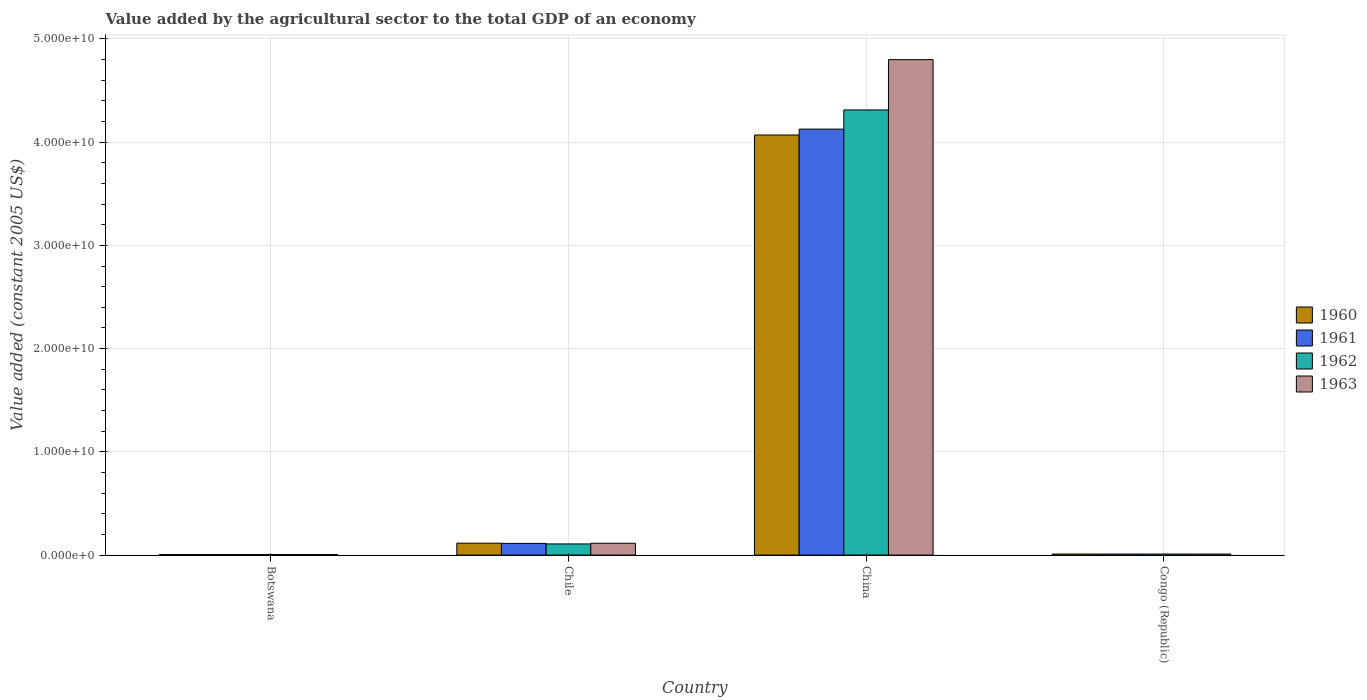Are the number of bars on each tick of the X-axis equal?
Offer a terse response. Yes. How many bars are there on the 1st tick from the left?
Provide a succinct answer. 4. How many bars are there on the 1st tick from the right?
Your answer should be very brief. 4. What is the label of the 2nd group of bars from the left?
Ensure brevity in your answer.  Chile. What is the value added by the agricultural sector in 1960 in China?
Your answer should be very brief. 4.07e+1. Across all countries, what is the maximum value added by the agricultural sector in 1963?
Keep it short and to the point. 4.80e+1. Across all countries, what is the minimum value added by the agricultural sector in 1962?
Keep it short and to the point. 5.04e+07. In which country was the value added by the agricultural sector in 1960 maximum?
Your answer should be very brief. China. In which country was the value added by the agricultural sector in 1963 minimum?
Your answer should be compact. Botswana. What is the total value added by the agricultural sector in 1960 in the graph?
Ensure brevity in your answer.  4.20e+1. What is the difference between the value added by the agricultural sector in 1960 in Botswana and that in China?
Give a very brief answer. -4.07e+1. What is the difference between the value added by the agricultural sector in 1963 in Chile and the value added by the agricultural sector in 1960 in Congo (Republic)?
Make the answer very short. 1.05e+09. What is the average value added by the agricultural sector in 1961 per country?
Your response must be concise. 1.06e+1. What is the difference between the value added by the agricultural sector of/in 1962 and value added by the agricultural sector of/in 1963 in Congo (Republic)?
Offer a very short reply. -6.85e+05. In how many countries, is the value added by the agricultural sector in 1963 greater than 34000000000 US$?
Offer a terse response. 1. What is the ratio of the value added by the agricultural sector in 1962 in Botswana to that in Congo (Republic)?
Offer a terse response. 0.51. Is the difference between the value added by the agricultural sector in 1962 in Chile and China greater than the difference between the value added by the agricultural sector in 1963 in Chile and China?
Ensure brevity in your answer.  Yes. What is the difference between the highest and the second highest value added by the agricultural sector in 1961?
Make the answer very short. 1.03e+09. What is the difference between the highest and the lowest value added by the agricultural sector in 1963?
Your answer should be compact. 4.79e+1. Is it the case that in every country, the sum of the value added by the agricultural sector in 1960 and value added by the agricultural sector in 1962 is greater than the value added by the agricultural sector in 1961?
Give a very brief answer. Yes. Are all the bars in the graph horizontal?
Keep it short and to the point. No. How many countries are there in the graph?
Offer a very short reply. 4. What is the difference between two consecutive major ticks on the Y-axis?
Provide a short and direct response. 1.00e+1. Does the graph contain any zero values?
Give a very brief answer. No. Does the graph contain grids?
Your answer should be very brief. Yes. Where does the legend appear in the graph?
Offer a very short reply. Center right. What is the title of the graph?
Give a very brief answer. Value added by the agricultural sector to the total GDP of an economy. What is the label or title of the X-axis?
Your response must be concise. Country. What is the label or title of the Y-axis?
Provide a succinct answer. Value added (constant 2005 US$). What is the Value added (constant 2005 US$) in 1960 in Botswana?
Your response must be concise. 4.74e+07. What is the Value added (constant 2005 US$) of 1961 in Botswana?
Provide a short and direct response. 4.86e+07. What is the Value added (constant 2005 US$) of 1962 in Botswana?
Ensure brevity in your answer.  5.04e+07. What is the Value added (constant 2005 US$) in 1963 in Botswana?
Offer a very short reply. 5.21e+07. What is the Value added (constant 2005 US$) in 1960 in Chile?
Your answer should be very brief. 1.15e+09. What is the Value added (constant 2005 US$) of 1961 in Chile?
Make the answer very short. 1.13e+09. What is the Value added (constant 2005 US$) in 1962 in Chile?
Your response must be concise. 1.08e+09. What is the Value added (constant 2005 US$) in 1963 in Chile?
Give a very brief answer. 1.15e+09. What is the Value added (constant 2005 US$) of 1960 in China?
Offer a terse response. 4.07e+1. What is the Value added (constant 2005 US$) in 1961 in China?
Provide a succinct answer. 4.13e+1. What is the Value added (constant 2005 US$) in 1962 in China?
Ensure brevity in your answer.  4.31e+1. What is the Value added (constant 2005 US$) in 1963 in China?
Give a very brief answer. 4.80e+1. What is the Value added (constant 2005 US$) of 1960 in Congo (Republic)?
Offer a terse response. 1.01e+08. What is the Value added (constant 2005 US$) of 1961 in Congo (Republic)?
Your response must be concise. 9.74e+07. What is the Value added (constant 2005 US$) of 1962 in Congo (Republic)?
Keep it short and to the point. 9.79e+07. What is the Value added (constant 2005 US$) in 1963 in Congo (Republic)?
Your answer should be very brief. 9.86e+07. Across all countries, what is the maximum Value added (constant 2005 US$) of 1960?
Make the answer very short. 4.07e+1. Across all countries, what is the maximum Value added (constant 2005 US$) of 1961?
Give a very brief answer. 4.13e+1. Across all countries, what is the maximum Value added (constant 2005 US$) of 1962?
Provide a succinct answer. 4.31e+1. Across all countries, what is the maximum Value added (constant 2005 US$) of 1963?
Your answer should be compact. 4.80e+1. Across all countries, what is the minimum Value added (constant 2005 US$) in 1960?
Provide a short and direct response. 4.74e+07. Across all countries, what is the minimum Value added (constant 2005 US$) of 1961?
Your answer should be very brief. 4.86e+07. Across all countries, what is the minimum Value added (constant 2005 US$) of 1962?
Make the answer very short. 5.04e+07. Across all countries, what is the minimum Value added (constant 2005 US$) in 1963?
Provide a succinct answer. 5.21e+07. What is the total Value added (constant 2005 US$) in 1960 in the graph?
Provide a succinct answer. 4.20e+1. What is the total Value added (constant 2005 US$) of 1961 in the graph?
Ensure brevity in your answer.  4.25e+1. What is the total Value added (constant 2005 US$) in 1962 in the graph?
Make the answer very short. 4.44e+1. What is the total Value added (constant 2005 US$) of 1963 in the graph?
Give a very brief answer. 4.93e+1. What is the difference between the Value added (constant 2005 US$) of 1960 in Botswana and that in Chile?
Ensure brevity in your answer.  -1.10e+09. What is the difference between the Value added (constant 2005 US$) in 1961 in Botswana and that in Chile?
Ensure brevity in your answer.  -1.08e+09. What is the difference between the Value added (constant 2005 US$) in 1962 in Botswana and that in Chile?
Give a very brief answer. -1.03e+09. What is the difference between the Value added (constant 2005 US$) of 1963 in Botswana and that in Chile?
Your response must be concise. -1.09e+09. What is the difference between the Value added (constant 2005 US$) of 1960 in Botswana and that in China?
Give a very brief answer. -4.07e+1. What is the difference between the Value added (constant 2005 US$) in 1961 in Botswana and that in China?
Ensure brevity in your answer.  -4.12e+1. What is the difference between the Value added (constant 2005 US$) of 1962 in Botswana and that in China?
Offer a terse response. -4.31e+1. What is the difference between the Value added (constant 2005 US$) in 1963 in Botswana and that in China?
Offer a terse response. -4.79e+1. What is the difference between the Value added (constant 2005 US$) of 1960 in Botswana and that in Congo (Republic)?
Make the answer very short. -5.35e+07. What is the difference between the Value added (constant 2005 US$) in 1961 in Botswana and that in Congo (Republic)?
Offer a terse response. -4.87e+07. What is the difference between the Value added (constant 2005 US$) in 1962 in Botswana and that in Congo (Republic)?
Offer a terse response. -4.76e+07. What is the difference between the Value added (constant 2005 US$) in 1963 in Botswana and that in Congo (Republic)?
Your answer should be compact. -4.65e+07. What is the difference between the Value added (constant 2005 US$) of 1960 in Chile and that in China?
Keep it short and to the point. -3.95e+1. What is the difference between the Value added (constant 2005 US$) of 1961 in Chile and that in China?
Give a very brief answer. -4.01e+1. What is the difference between the Value added (constant 2005 US$) of 1962 in Chile and that in China?
Offer a very short reply. -4.20e+1. What is the difference between the Value added (constant 2005 US$) in 1963 in Chile and that in China?
Your response must be concise. -4.69e+1. What is the difference between the Value added (constant 2005 US$) of 1960 in Chile and that in Congo (Republic)?
Your response must be concise. 1.05e+09. What is the difference between the Value added (constant 2005 US$) of 1961 in Chile and that in Congo (Republic)?
Give a very brief answer. 1.03e+09. What is the difference between the Value added (constant 2005 US$) of 1962 in Chile and that in Congo (Republic)?
Give a very brief answer. 9.81e+08. What is the difference between the Value added (constant 2005 US$) in 1963 in Chile and that in Congo (Republic)?
Offer a very short reply. 1.05e+09. What is the difference between the Value added (constant 2005 US$) of 1960 in China and that in Congo (Republic)?
Provide a succinct answer. 4.06e+1. What is the difference between the Value added (constant 2005 US$) in 1961 in China and that in Congo (Republic)?
Offer a very short reply. 4.12e+1. What is the difference between the Value added (constant 2005 US$) in 1962 in China and that in Congo (Republic)?
Ensure brevity in your answer.  4.30e+1. What is the difference between the Value added (constant 2005 US$) of 1963 in China and that in Congo (Republic)?
Provide a short and direct response. 4.79e+1. What is the difference between the Value added (constant 2005 US$) in 1960 in Botswana and the Value added (constant 2005 US$) in 1961 in Chile?
Give a very brief answer. -1.08e+09. What is the difference between the Value added (constant 2005 US$) of 1960 in Botswana and the Value added (constant 2005 US$) of 1962 in Chile?
Offer a terse response. -1.03e+09. What is the difference between the Value added (constant 2005 US$) in 1960 in Botswana and the Value added (constant 2005 US$) in 1963 in Chile?
Keep it short and to the point. -1.10e+09. What is the difference between the Value added (constant 2005 US$) of 1961 in Botswana and the Value added (constant 2005 US$) of 1962 in Chile?
Keep it short and to the point. -1.03e+09. What is the difference between the Value added (constant 2005 US$) of 1961 in Botswana and the Value added (constant 2005 US$) of 1963 in Chile?
Ensure brevity in your answer.  -1.10e+09. What is the difference between the Value added (constant 2005 US$) in 1962 in Botswana and the Value added (constant 2005 US$) in 1963 in Chile?
Offer a terse response. -1.10e+09. What is the difference between the Value added (constant 2005 US$) of 1960 in Botswana and the Value added (constant 2005 US$) of 1961 in China?
Your answer should be very brief. -4.12e+1. What is the difference between the Value added (constant 2005 US$) in 1960 in Botswana and the Value added (constant 2005 US$) in 1962 in China?
Provide a short and direct response. -4.31e+1. What is the difference between the Value added (constant 2005 US$) in 1960 in Botswana and the Value added (constant 2005 US$) in 1963 in China?
Your answer should be compact. -4.80e+1. What is the difference between the Value added (constant 2005 US$) of 1961 in Botswana and the Value added (constant 2005 US$) of 1962 in China?
Provide a short and direct response. -4.31e+1. What is the difference between the Value added (constant 2005 US$) in 1961 in Botswana and the Value added (constant 2005 US$) in 1963 in China?
Provide a succinct answer. -4.79e+1. What is the difference between the Value added (constant 2005 US$) in 1962 in Botswana and the Value added (constant 2005 US$) in 1963 in China?
Offer a very short reply. -4.79e+1. What is the difference between the Value added (constant 2005 US$) of 1960 in Botswana and the Value added (constant 2005 US$) of 1961 in Congo (Republic)?
Offer a terse response. -4.99e+07. What is the difference between the Value added (constant 2005 US$) of 1960 in Botswana and the Value added (constant 2005 US$) of 1962 in Congo (Republic)?
Offer a very short reply. -5.05e+07. What is the difference between the Value added (constant 2005 US$) in 1960 in Botswana and the Value added (constant 2005 US$) in 1963 in Congo (Republic)?
Keep it short and to the point. -5.12e+07. What is the difference between the Value added (constant 2005 US$) of 1961 in Botswana and the Value added (constant 2005 US$) of 1962 in Congo (Republic)?
Keep it short and to the point. -4.93e+07. What is the difference between the Value added (constant 2005 US$) of 1961 in Botswana and the Value added (constant 2005 US$) of 1963 in Congo (Republic)?
Offer a very short reply. -5.00e+07. What is the difference between the Value added (constant 2005 US$) in 1962 in Botswana and the Value added (constant 2005 US$) in 1963 in Congo (Republic)?
Keep it short and to the point. -4.83e+07. What is the difference between the Value added (constant 2005 US$) of 1960 in Chile and the Value added (constant 2005 US$) of 1961 in China?
Offer a very short reply. -4.01e+1. What is the difference between the Value added (constant 2005 US$) in 1960 in Chile and the Value added (constant 2005 US$) in 1962 in China?
Your answer should be compact. -4.20e+1. What is the difference between the Value added (constant 2005 US$) in 1960 in Chile and the Value added (constant 2005 US$) in 1963 in China?
Give a very brief answer. -4.68e+1. What is the difference between the Value added (constant 2005 US$) of 1961 in Chile and the Value added (constant 2005 US$) of 1962 in China?
Provide a succinct answer. -4.20e+1. What is the difference between the Value added (constant 2005 US$) of 1961 in Chile and the Value added (constant 2005 US$) of 1963 in China?
Provide a short and direct response. -4.69e+1. What is the difference between the Value added (constant 2005 US$) of 1962 in Chile and the Value added (constant 2005 US$) of 1963 in China?
Make the answer very short. -4.69e+1. What is the difference between the Value added (constant 2005 US$) in 1960 in Chile and the Value added (constant 2005 US$) in 1961 in Congo (Republic)?
Provide a succinct answer. 1.05e+09. What is the difference between the Value added (constant 2005 US$) of 1960 in Chile and the Value added (constant 2005 US$) of 1962 in Congo (Republic)?
Make the answer very short. 1.05e+09. What is the difference between the Value added (constant 2005 US$) in 1960 in Chile and the Value added (constant 2005 US$) in 1963 in Congo (Republic)?
Your response must be concise. 1.05e+09. What is the difference between the Value added (constant 2005 US$) in 1961 in Chile and the Value added (constant 2005 US$) in 1962 in Congo (Republic)?
Make the answer very short. 1.03e+09. What is the difference between the Value added (constant 2005 US$) in 1961 in Chile and the Value added (constant 2005 US$) in 1963 in Congo (Republic)?
Offer a very short reply. 1.03e+09. What is the difference between the Value added (constant 2005 US$) in 1962 in Chile and the Value added (constant 2005 US$) in 1963 in Congo (Republic)?
Your answer should be compact. 9.81e+08. What is the difference between the Value added (constant 2005 US$) of 1960 in China and the Value added (constant 2005 US$) of 1961 in Congo (Republic)?
Offer a terse response. 4.06e+1. What is the difference between the Value added (constant 2005 US$) of 1960 in China and the Value added (constant 2005 US$) of 1962 in Congo (Republic)?
Offer a terse response. 4.06e+1. What is the difference between the Value added (constant 2005 US$) in 1960 in China and the Value added (constant 2005 US$) in 1963 in Congo (Republic)?
Make the answer very short. 4.06e+1. What is the difference between the Value added (constant 2005 US$) of 1961 in China and the Value added (constant 2005 US$) of 1962 in Congo (Republic)?
Make the answer very short. 4.12e+1. What is the difference between the Value added (constant 2005 US$) of 1961 in China and the Value added (constant 2005 US$) of 1963 in Congo (Republic)?
Give a very brief answer. 4.12e+1. What is the difference between the Value added (constant 2005 US$) in 1962 in China and the Value added (constant 2005 US$) in 1963 in Congo (Republic)?
Ensure brevity in your answer.  4.30e+1. What is the average Value added (constant 2005 US$) of 1960 per country?
Provide a succinct answer. 1.05e+1. What is the average Value added (constant 2005 US$) of 1961 per country?
Keep it short and to the point. 1.06e+1. What is the average Value added (constant 2005 US$) of 1962 per country?
Ensure brevity in your answer.  1.11e+1. What is the average Value added (constant 2005 US$) in 1963 per country?
Ensure brevity in your answer.  1.23e+1. What is the difference between the Value added (constant 2005 US$) in 1960 and Value added (constant 2005 US$) in 1961 in Botswana?
Provide a short and direct response. -1.17e+06. What is the difference between the Value added (constant 2005 US$) of 1960 and Value added (constant 2005 US$) of 1962 in Botswana?
Keep it short and to the point. -2.92e+06. What is the difference between the Value added (constant 2005 US$) of 1960 and Value added (constant 2005 US$) of 1963 in Botswana?
Offer a terse response. -4.67e+06. What is the difference between the Value added (constant 2005 US$) in 1961 and Value added (constant 2005 US$) in 1962 in Botswana?
Your answer should be very brief. -1.75e+06. What is the difference between the Value added (constant 2005 US$) of 1961 and Value added (constant 2005 US$) of 1963 in Botswana?
Offer a terse response. -3.51e+06. What is the difference between the Value added (constant 2005 US$) in 1962 and Value added (constant 2005 US$) in 1963 in Botswana?
Make the answer very short. -1.75e+06. What is the difference between the Value added (constant 2005 US$) of 1960 and Value added (constant 2005 US$) of 1961 in Chile?
Your answer should be very brief. 2.12e+07. What is the difference between the Value added (constant 2005 US$) in 1960 and Value added (constant 2005 US$) in 1962 in Chile?
Make the answer very short. 7.27e+07. What is the difference between the Value added (constant 2005 US$) in 1960 and Value added (constant 2005 US$) in 1963 in Chile?
Your answer should be very brief. 5.74e+06. What is the difference between the Value added (constant 2005 US$) of 1961 and Value added (constant 2005 US$) of 1962 in Chile?
Offer a very short reply. 5.15e+07. What is the difference between the Value added (constant 2005 US$) of 1961 and Value added (constant 2005 US$) of 1963 in Chile?
Ensure brevity in your answer.  -1.54e+07. What is the difference between the Value added (constant 2005 US$) in 1962 and Value added (constant 2005 US$) in 1963 in Chile?
Offer a very short reply. -6.69e+07. What is the difference between the Value added (constant 2005 US$) of 1960 and Value added (constant 2005 US$) of 1961 in China?
Offer a terse response. -5.70e+08. What is the difference between the Value added (constant 2005 US$) in 1960 and Value added (constant 2005 US$) in 1962 in China?
Make the answer very short. -2.43e+09. What is the difference between the Value added (constant 2005 US$) in 1960 and Value added (constant 2005 US$) in 1963 in China?
Provide a succinct answer. -7.30e+09. What is the difference between the Value added (constant 2005 US$) of 1961 and Value added (constant 2005 US$) of 1962 in China?
Your response must be concise. -1.86e+09. What is the difference between the Value added (constant 2005 US$) in 1961 and Value added (constant 2005 US$) in 1963 in China?
Offer a very short reply. -6.73e+09. What is the difference between the Value added (constant 2005 US$) in 1962 and Value added (constant 2005 US$) in 1963 in China?
Ensure brevity in your answer.  -4.87e+09. What is the difference between the Value added (constant 2005 US$) in 1960 and Value added (constant 2005 US$) in 1961 in Congo (Republic)?
Keep it short and to the point. 3.61e+06. What is the difference between the Value added (constant 2005 US$) in 1960 and Value added (constant 2005 US$) in 1962 in Congo (Republic)?
Provide a succinct answer. 3.02e+06. What is the difference between the Value added (constant 2005 US$) of 1960 and Value added (constant 2005 US$) of 1963 in Congo (Republic)?
Give a very brief answer. 2.34e+06. What is the difference between the Value added (constant 2005 US$) in 1961 and Value added (constant 2005 US$) in 1962 in Congo (Republic)?
Provide a succinct answer. -5.86e+05. What is the difference between the Value added (constant 2005 US$) of 1961 and Value added (constant 2005 US$) of 1963 in Congo (Republic)?
Your answer should be very brief. -1.27e+06. What is the difference between the Value added (constant 2005 US$) of 1962 and Value added (constant 2005 US$) of 1963 in Congo (Republic)?
Ensure brevity in your answer.  -6.85e+05. What is the ratio of the Value added (constant 2005 US$) of 1960 in Botswana to that in Chile?
Provide a short and direct response. 0.04. What is the ratio of the Value added (constant 2005 US$) in 1961 in Botswana to that in Chile?
Make the answer very short. 0.04. What is the ratio of the Value added (constant 2005 US$) in 1962 in Botswana to that in Chile?
Offer a very short reply. 0.05. What is the ratio of the Value added (constant 2005 US$) in 1963 in Botswana to that in Chile?
Provide a succinct answer. 0.05. What is the ratio of the Value added (constant 2005 US$) of 1960 in Botswana to that in China?
Make the answer very short. 0. What is the ratio of the Value added (constant 2005 US$) in 1961 in Botswana to that in China?
Make the answer very short. 0. What is the ratio of the Value added (constant 2005 US$) in 1962 in Botswana to that in China?
Make the answer very short. 0. What is the ratio of the Value added (constant 2005 US$) of 1963 in Botswana to that in China?
Offer a terse response. 0. What is the ratio of the Value added (constant 2005 US$) in 1960 in Botswana to that in Congo (Republic)?
Provide a succinct answer. 0.47. What is the ratio of the Value added (constant 2005 US$) in 1961 in Botswana to that in Congo (Republic)?
Offer a terse response. 0.5. What is the ratio of the Value added (constant 2005 US$) in 1962 in Botswana to that in Congo (Republic)?
Keep it short and to the point. 0.51. What is the ratio of the Value added (constant 2005 US$) in 1963 in Botswana to that in Congo (Republic)?
Provide a succinct answer. 0.53. What is the ratio of the Value added (constant 2005 US$) of 1960 in Chile to that in China?
Keep it short and to the point. 0.03. What is the ratio of the Value added (constant 2005 US$) in 1961 in Chile to that in China?
Offer a very short reply. 0.03. What is the ratio of the Value added (constant 2005 US$) of 1962 in Chile to that in China?
Make the answer very short. 0.03. What is the ratio of the Value added (constant 2005 US$) of 1963 in Chile to that in China?
Give a very brief answer. 0.02. What is the ratio of the Value added (constant 2005 US$) in 1960 in Chile to that in Congo (Republic)?
Your response must be concise. 11.41. What is the ratio of the Value added (constant 2005 US$) in 1961 in Chile to that in Congo (Republic)?
Provide a short and direct response. 11.61. What is the ratio of the Value added (constant 2005 US$) in 1962 in Chile to that in Congo (Republic)?
Make the answer very short. 11.02. What is the ratio of the Value added (constant 2005 US$) in 1963 in Chile to that in Congo (Republic)?
Your response must be concise. 11.62. What is the ratio of the Value added (constant 2005 US$) of 1960 in China to that in Congo (Republic)?
Your response must be concise. 403.12. What is the ratio of the Value added (constant 2005 US$) in 1961 in China to that in Congo (Republic)?
Keep it short and to the point. 423.9. What is the ratio of the Value added (constant 2005 US$) in 1962 in China to that in Congo (Republic)?
Keep it short and to the point. 440.32. What is the ratio of the Value added (constant 2005 US$) in 1963 in China to that in Congo (Republic)?
Provide a short and direct response. 486.68. What is the difference between the highest and the second highest Value added (constant 2005 US$) in 1960?
Keep it short and to the point. 3.95e+1. What is the difference between the highest and the second highest Value added (constant 2005 US$) in 1961?
Offer a very short reply. 4.01e+1. What is the difference between the highest and the second highest Value added (constant 2005 US$) of 1962?
Offer a very short reply. 4.20e+1. What is the difference between the highest and the second highest Value added (constant 2005 US$) of 1963?
Give a very brief answer. 4.69e+1. What is the difference between the highest and the lowest Value added (constant 2005 US$) in 1960?
Offer a very short reply. 4.07e+1. What is the difference between the highest and the lowest Value added (constant 2005 US$) in 1961?
Offer a very short reply. 4.12e+1. What is the difference between the highest and the lowest Value added (constant 2005 US$) in 1962?
Make the answer very short. 4.31e+1. What is the difference between the highest and the lowest Value added (constant 2005 US$) in 1963?
Offer a terse response. 4.79e+1. 